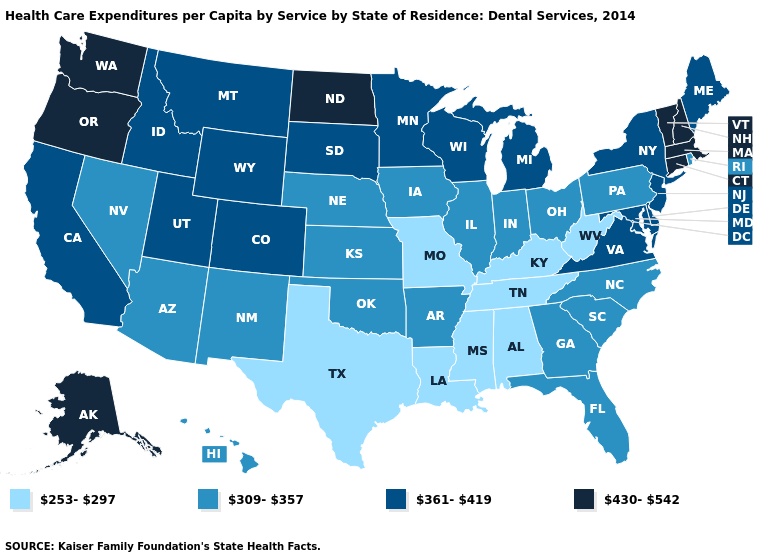What is the highest value in states that border Massachusetts?
Be succinct. 430-542. Which states have the lowest value in the MidWest?
Concise answer only. Missouri. What is the value of Pennsylvania?
Be succinct. 309-357. Name the states that have a value in the range 309-357?
Keep it brief. Arizona, Arkansas, Florida, Georgia, Hawaii, Illinois, Indiana, Iowa, Kansas, Nebraska, Nevada, New Mexico, North Carolina, Ohio, Oklahoma, Pennsylvania, Rhode Island, South Carolina. What is the highest value in states that border Ohio?
Write a very short answer. 361-419. Name the states that have a value in the range 361-419?
Quick response, please. California, Colorado, Delaware, Idaho, Maine, Maryland, Michigan, Minnesota, Montana, New Jersey, New York, South Dakota, Utah, Virginia, Wisconsin, Wyoming. Does North Dakota have the highest value in the MidWest?
Be succinct. Yes. Name the states that have a value in the range 309-357?
Keep it brief. Arizona, Arkansas, Florida, Georgia, Hawaii, Illinois, Indiana, Iowa, Kansas, Nebraska, Nevada, New Mexico, North Carolina, Ohio, Oklahoma, Pennsylvania, Rhode Island, South Carolina. Which states have the highest value in the USA?
Give a very brief answer. Alaska, Connecticut, Massachusetts, New Hampshire, North Dakota, Oregon, Vermont, Washington. What is the lowest value in the USA?
Write a very short answer. 253-297. What is the lowest value in the USA?
Keep it brief. 253-297. Among the states that border Oregon , which have the lowest value?
Answer briefly. Nevada. Name the states that have a value in the range 253-297?
Concise answer only. Alabama, Kentucky, Louisiana, Mississippi, Missouri, Tennessee, Texas, West Virginia. Is the legend a continuous bar?
Give a very brief answer. No. 